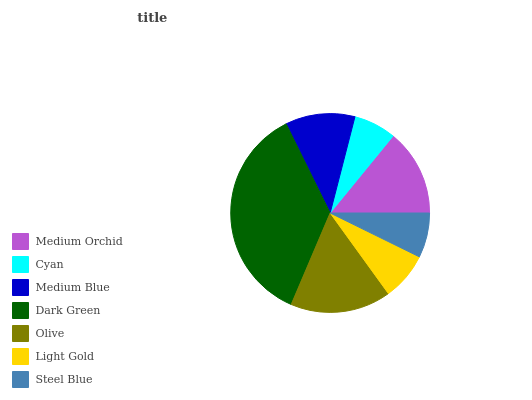Is Cyan the minimum?
Answer yes or no. Yes. Is Dark Green the maximum?
Answer yes or no. Yes. Is Medium Blue the minimum?
Answer yes or no. No. Is Medium Blue the maximum?
Answer yes or no. No. Is Medium Blue greater than Cyan?
Answer yes or no. Yes. Is Cyan less than Medium Blue?
Answer yes or no. Yes. Is Cyan greater than Medium Blue?
Answer yes or no. No. Is Medium Blue less than Cyan?
Answer yes or no. No. Is Medium Blue the high median?
Answer yes or no. Yes. Is Medium Blue the low median?
Answer yes or no. Yes. Is Olive the high median?
Answer yes or no. No. Is Dark Green the low median?
Answer yes or no. No. 